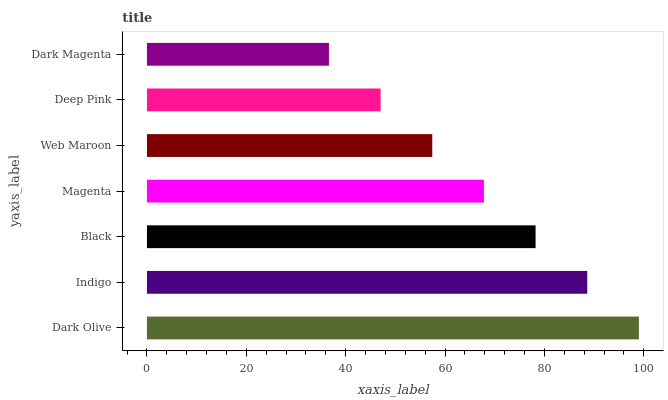Is Dark Magenta the minimum?
Answer yes or no. Yes. Is Dark Olive the maximum?
Answer yes or no. Yes. Is Indigo the minimum?
Answer yes or no. No. Is Indigo the maximum?
Answer yes or no. No. Is Dark Olive greater than Indigo?
Answer yes or no. Yes. Is Indigo less than Dark Olive?
Answer yes or no. Yes. Is Indigo greater than Dark Olive?
Answer yes or no. No. Is Dark Olive less than Indigo?
Answer yes or no. No. Is Magenta the high median?
Answer yes or no. Yes. Is Magenta the low median?
Answer yes or no. Yes. Is Black the high median?
Answer yes or no. No. Is Dark Olive the low median?
Answer yes or no. No. 